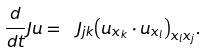Convert formula to latex. <formula><loc_0><loc_0><loc_500><loc_500>\frac { d } { d t } J u = { { { \ J _ { j k } } { { { \left ( { u _ { x _ { k } } } \cdot { u _ { x _ { l } } } \right ) } _ { { x _ { l } } { x _ { j } } } } } } } .</formula> 